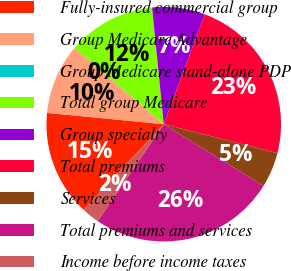Convert chart. <chart><loc_0><loc_0><loc_500><loc_500><pie_chart><fcel>Fully-insured commercial group<fcel>Group Medicare Advantage<fcel>Group Medicare stand-alone PDP<fcel>Total group Medicare<fcel>Group specialty<fcel>Total premiums<fcel>Services<fcel>Total premiums and services<fcel>Income before income taxes<nl><fcel>14.57%<fcel>9.72%<fcel>0.01%<fcel>12.14%<fcel>7.29%<fcel>23.26%<fcel>4.87%<fcel>25.69%<fcel>2.44%<nl></chart> 